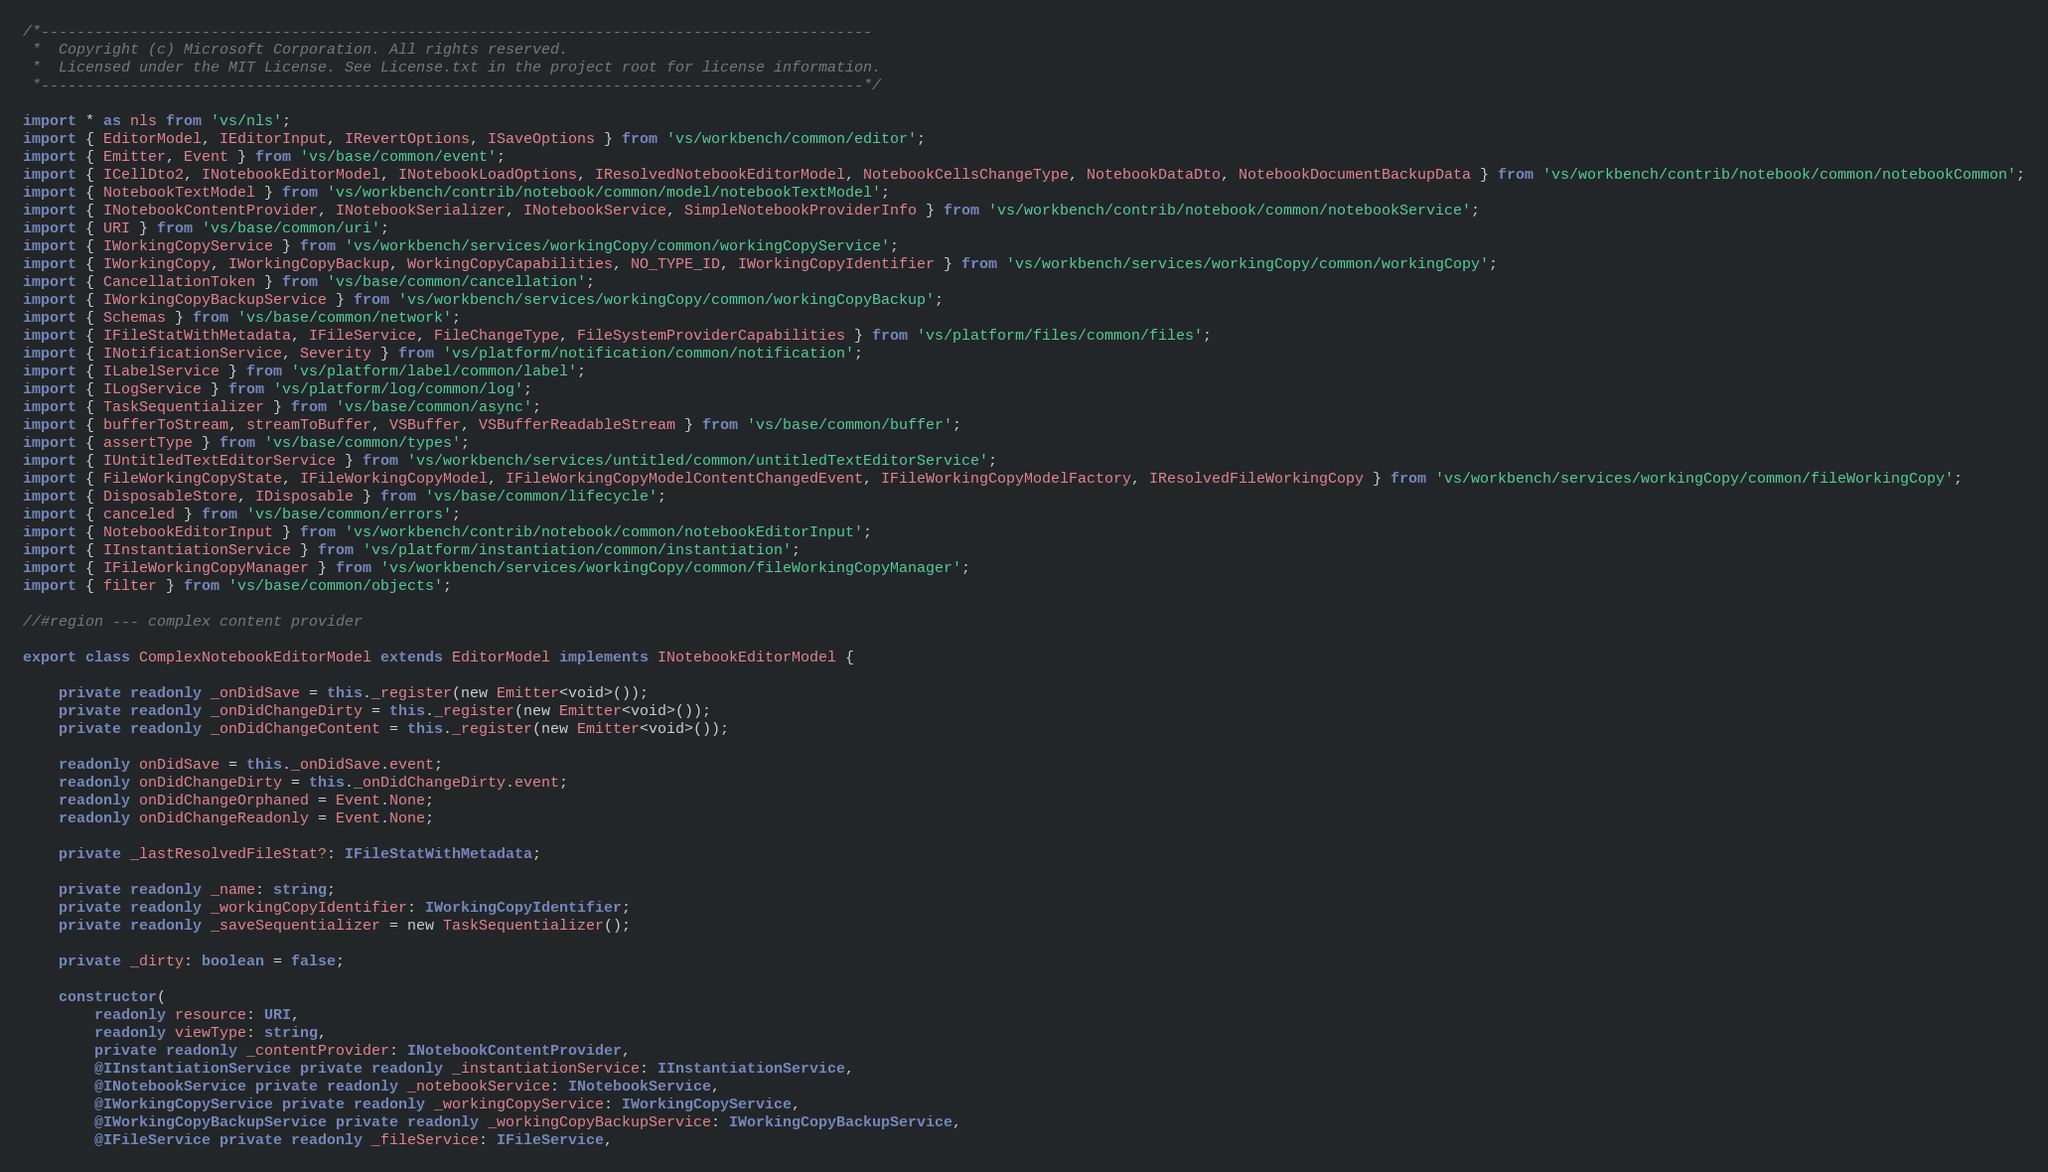<code> <loc_0><loc_0><loc_500><loc_500><_TypeScript_>/*---------------------------------------------------------------------------------------------
 *  Copyright (c) Microsoft Corporation. All rights reserved.
 *  Licensed under the MIT License. See License.txt in the project root for license information.
 *--------------------------------------------------------------------------------------------*/

import * as nls from 'vs/nls';
import { EditorModel, IEditorInput, IRevertOptions, ISaveOptions } from 'vs/workbench/common/editor';
import { Emitter, Event } from 'vs/base/common/event';
import { ICellDto2, INotebookEditorModel, INotebookLoadOptions, IResolvedNotebookEditorModel, NotebookCellsChangeType, NotebookDataDto, NotebookDocumentBackupData } from 'vs/workbench/contrib/notebook/common/notebookCommon';
import { NotebookTextModel } from 'vs/workbench/contrib/notebook/common/model/notebookTextModel';
import { INotebookContentProvider, INotebookSerializer, INotebookService, SimpleNotebookProviderInfo } from 'vs/workbench/contrib/notebook/common/notebookService';
import { URI } from 'vs/base/common/uri';
import { IWorkingCopyService } from 'vs/workbench/services/workingCopy/common/workingCopyService';
import { IWorkingCopy, IWorkingCopyBackup, WorkingCopyCapabilities, NO_TYPE_ID, IWorkingCopyIdentifier } from 'vs/workbench/services/workingCopy/common/workingCopy';
import { CancellationToken } from 'vs/base/common/cancellation';
import { IWorkingCopyBackupService } from 'vs/workbench/services/workingCopy/common/workingCopyBackup';
import { Schemas } from 'vs/base/common/network';
import { IFileStatWithMetadata, IFileService, FileChangeType, FileSystemProviderCapabilities } from 'vs/platform/files/common/files';
import { INotificationService, Severity } from 'vs/platform/notification/common/notification';
import { ILabelService } from 'vs/platform/label/common/label';
import { ILogService } from 'vs/platform/log/common/log';
import { TaskSequentializer } from 'vs/base/common/async';
import { bufferToStream, streamToBuffer, VSBuffer, VSBufferReadableStream } from 'vs/base/common/buffer';
import { assertType } from 'vs/base/common/types';
import { IUntitledTextEditorService } from 'vs/workbench/services/untitled/common/untitledTextEditorService';
import { FileWorkingCopyState, IFileWorkingCopyModel, IFileWorkingCopyModelContentChangedEvent, IFileWorkingCopyModelFactory, IResolvedFileWorkingCopy } from 'vs/workbench/services/workingCopy/common/fileWorkingCopy';
import { DisposableStore, IDisposable } from 'vs/base/common/lifecycle';
import { canceled } from 'vs/base/common/errors';
import { NotebookEditorInput } from 'vs/workbench/contrib/notebook/common/notebookEditorInput';
import { IInstantiationService } from 'vs/platform/instantiation/common/instantiation';
import { IFileWorkingCopyManager } from 'vs/workbench/services/workingCopy/common/fileWorkingCopyManager';
import { filter } from 'vs/base/common/objects';

//#region --- complex content provider

export class ComplexNotebookEditorModel extends EditorModel implements INotebookEditorModel {

	private readonly _onDidSave = this._register(new Emitter<void>());
	private readonly _onDidChangeDirty = this._register(new Emitter<void>());
	private readonly _onDidChangeContent = this._register(new Emitter<void>());

	readonly onDidSave = this._onDidSave.event;
	readonly onDidChangeDirty = this._onDidChangeDirty.event;
	readonly onDidChangeOrphaned = Event.None;
	readonly onDidChangeReadonly = Event.None;

	private _lastResolvedFileStat?: IFileStatWithMetadata;

	private readonly _name: string;
	private readonly _workingCopyIdentifier: IWorkingCopyIdentifier;
	private readonly _saveSequentializer = new TaskSequentializer();

	private _dirty: boolean = false;

	constructor(
		readonly resource: URI,
		readonly viewType: string,
		private readonly _contentProvider: INotebookContentProvider,
		@IInstantiationService private readonly _instantiationService: IInstantiationService,
		@INotebookService private readonly _notebookService: INotebookService,
		@IWorkingCopyService private readonly _workingCopyService: IWorkingCopyService,
		@IWorkingCopyBackupService private readonly _workingCopyBackupService: IWorkingCopyBackupService,
		@IFileService private readonly _fileService: IFileService,</code> 